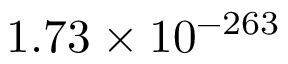<formula> <loc_0><loc_0><loc_500><loc_500>1 . 7 3 \times 1 0 ^ { - 2 6 3 }</formula> 